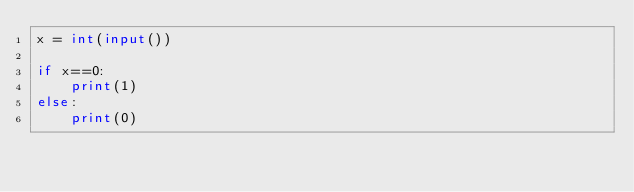Convert code to text. <code><loc_0><loc_0><loc_500><loc_500><_Python_>x = int(input())

if x==0:
    print(1)
else:
    print(0)</code> 